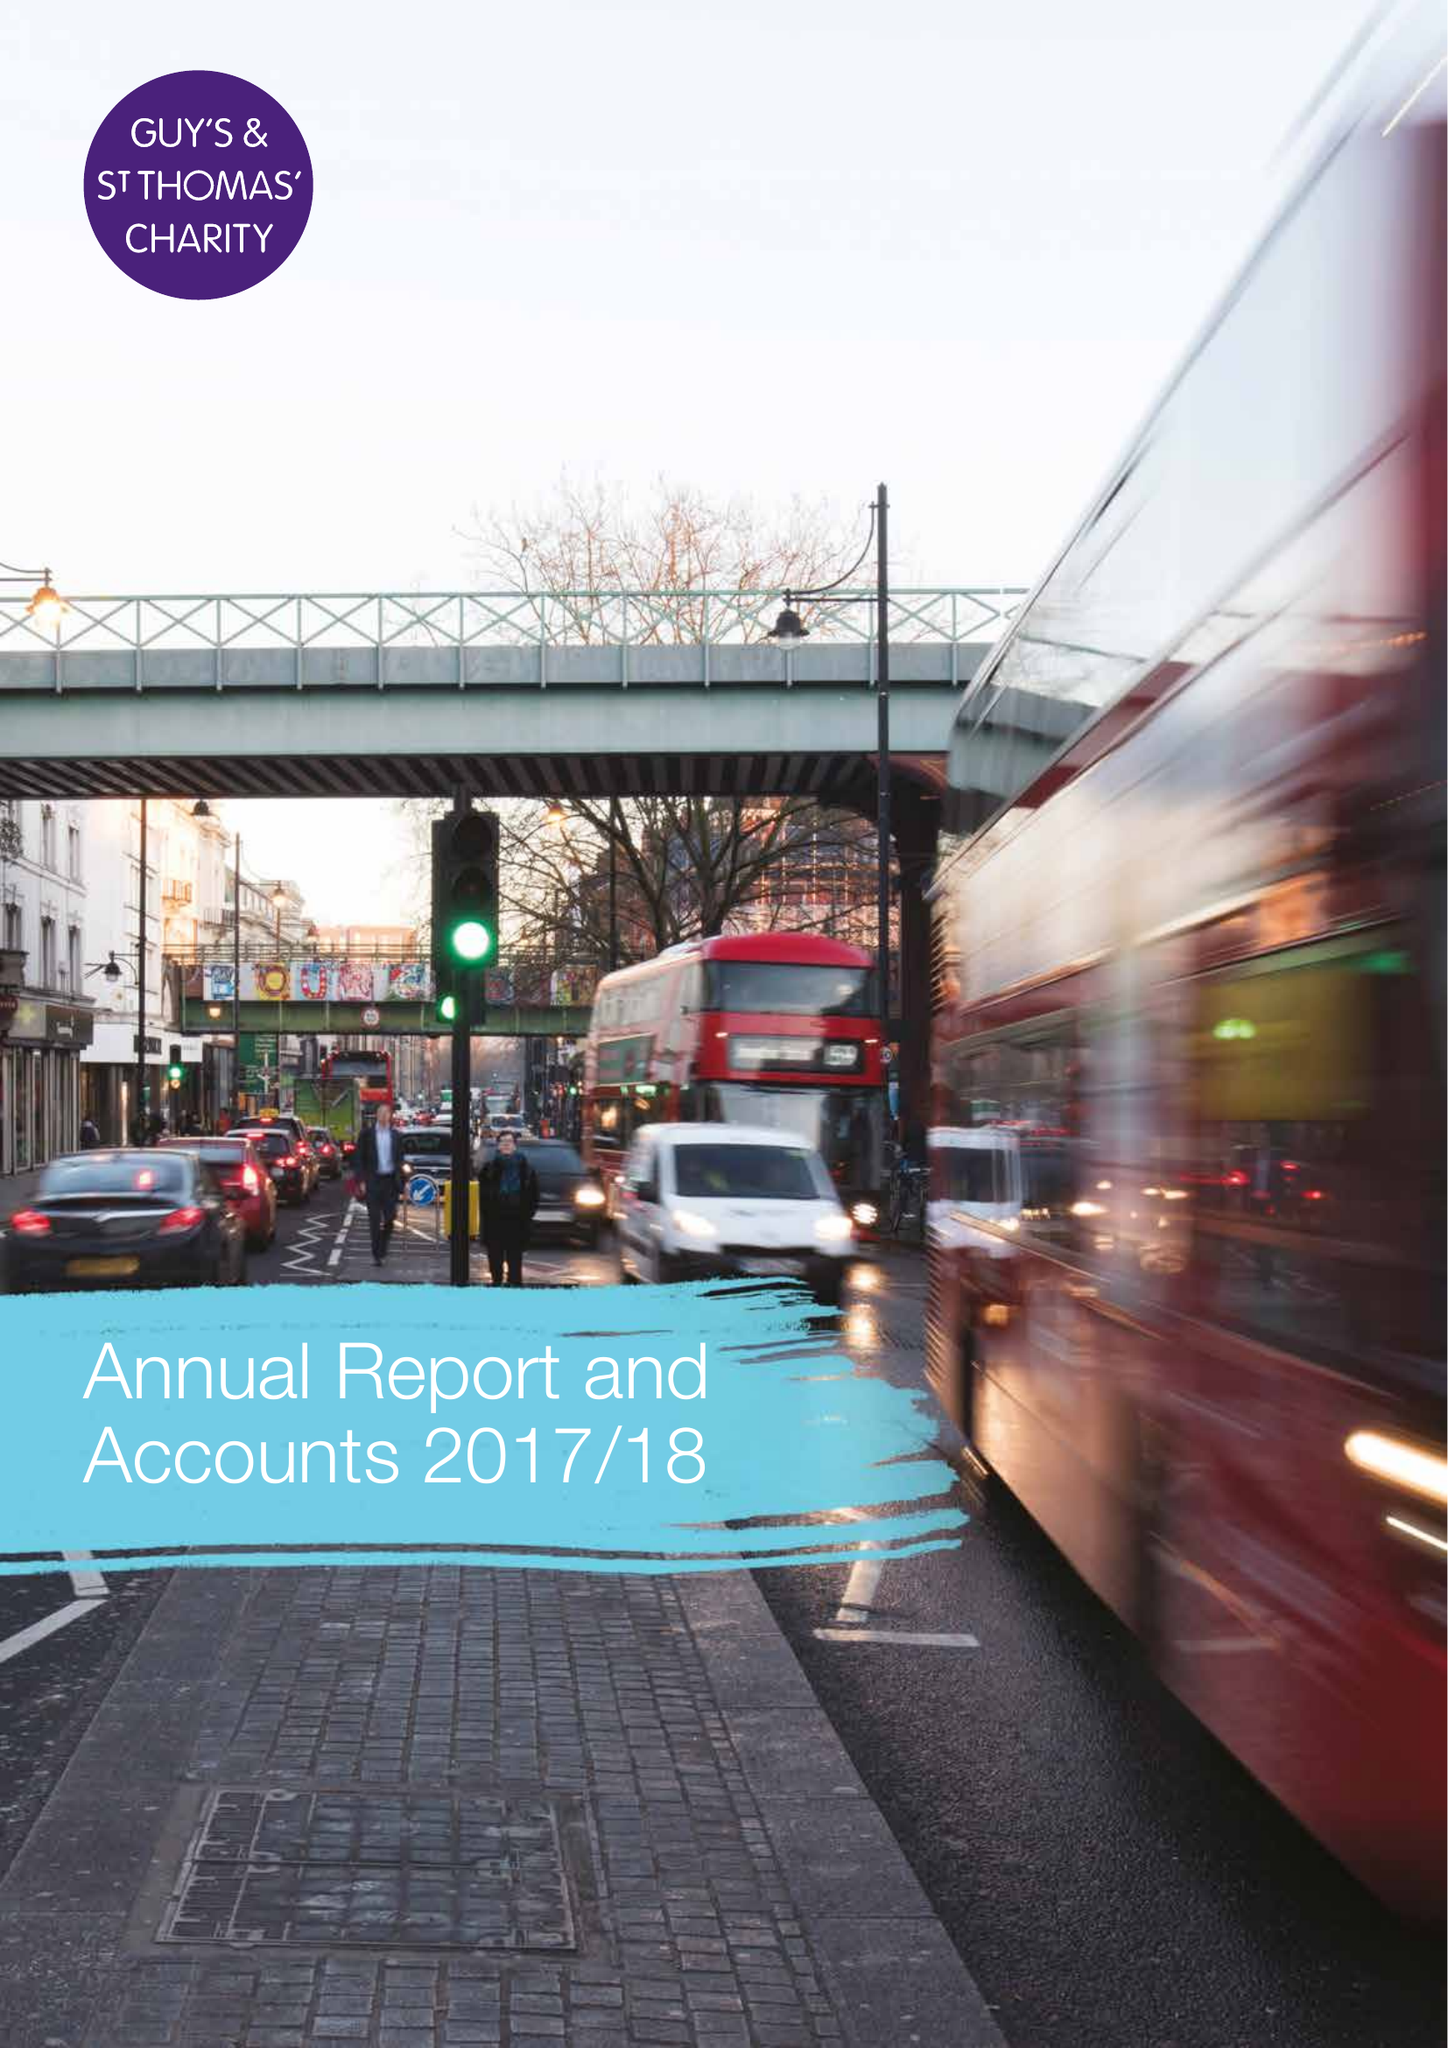What is the value for the spending_annually_in_british_pounds?
Answer the question using a single word or phrase. 40633000.00 